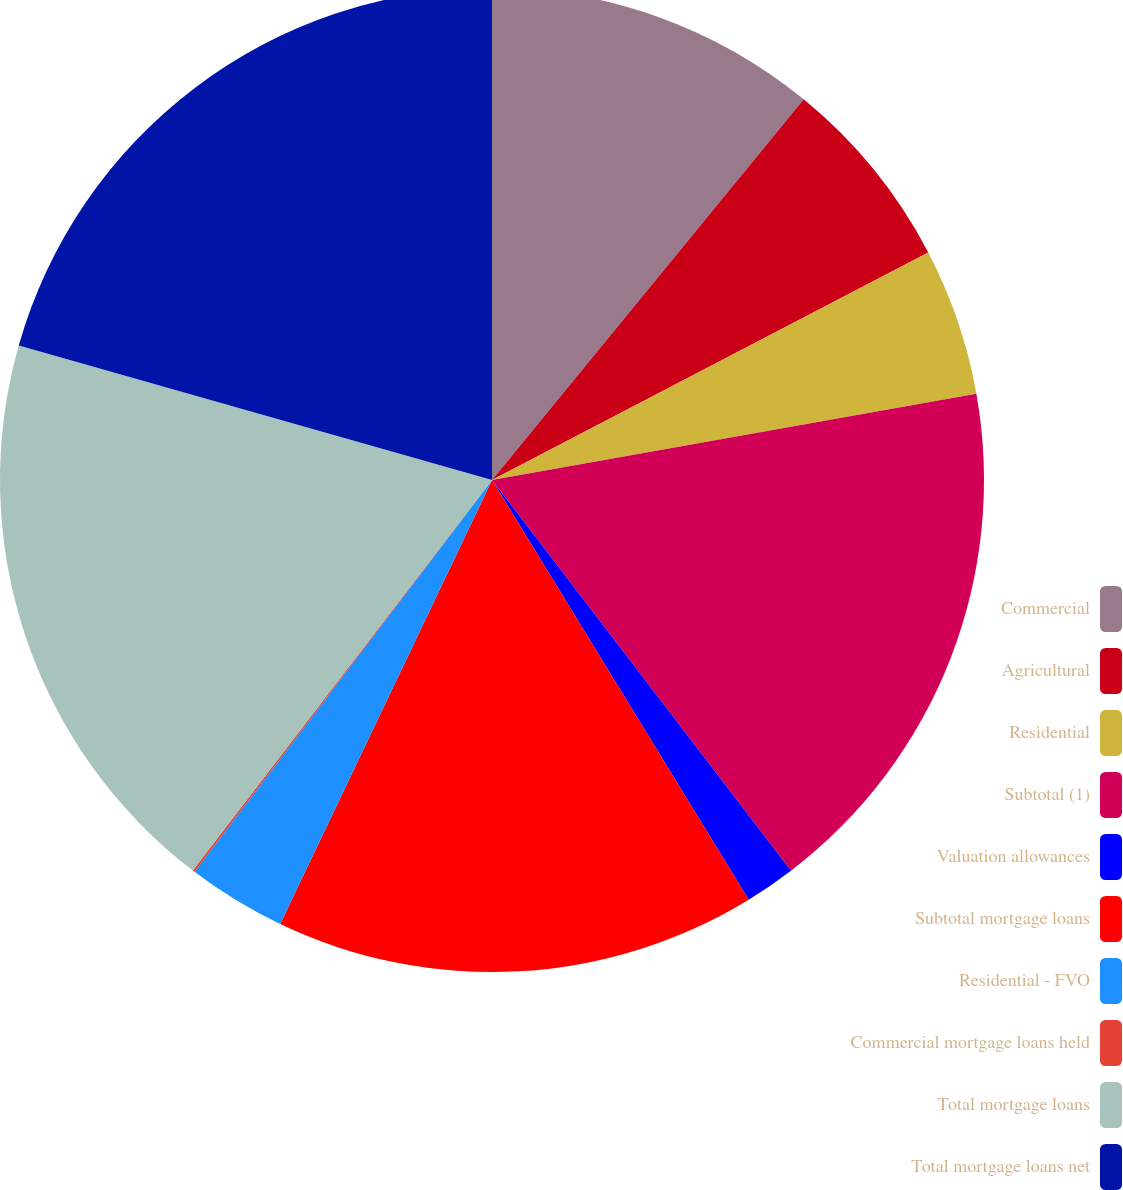Convert chart to OTSL. <chart><loc_0><loc_0><loc_500><loc_500><pie_chart><fcel>Commercial<fcel>Agricultural<fcel>Residential<fcel>Subtotal (1)<fcel>Valuation allowances<fcel>Subtotal mortgage loans<fcel>Residential - FVO<fcel>Commercial mortgage loans held<fcel>Total mortgage loans<fcel>Total mortgage loans net<nl><fcel>10.92%<fcel>6.43%<fcel>4.84%<fcel>17.41%<fcel>1.66%<fcel>15.82%<fcel>3.25%<fcel>0.07%<fcel>19.0%<fcel>20.59%<nl></chart> 